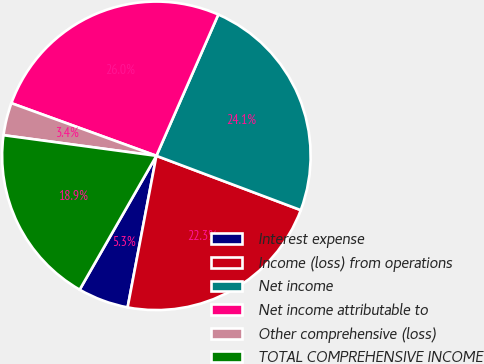Convert chart to OTSL. <chart><loc_0><loc_0><loc_500><loc_500><pie_chart><fcel>Interest expense<fcel>Income (loss) from operations<fcel>Net income<fcel>Net income attributable to<fcel>Other comprehensive (loss)<fcel>TOTAL COMPREHENSIVE INCOME<nl><fcel>5.3%<fcel>22.26%<fcel>24.15%<fcel>26.03%<fcel>3.41%<fcel>18.85%<nl></chart> 